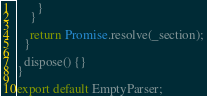<code> <loc_0><loc_0><loc_500><loc_500><_JavaScript_>      }
    }

    return Promise.resolve(_section);
  }

  dispose() {}
}

export default EmptyParser;
</code> 